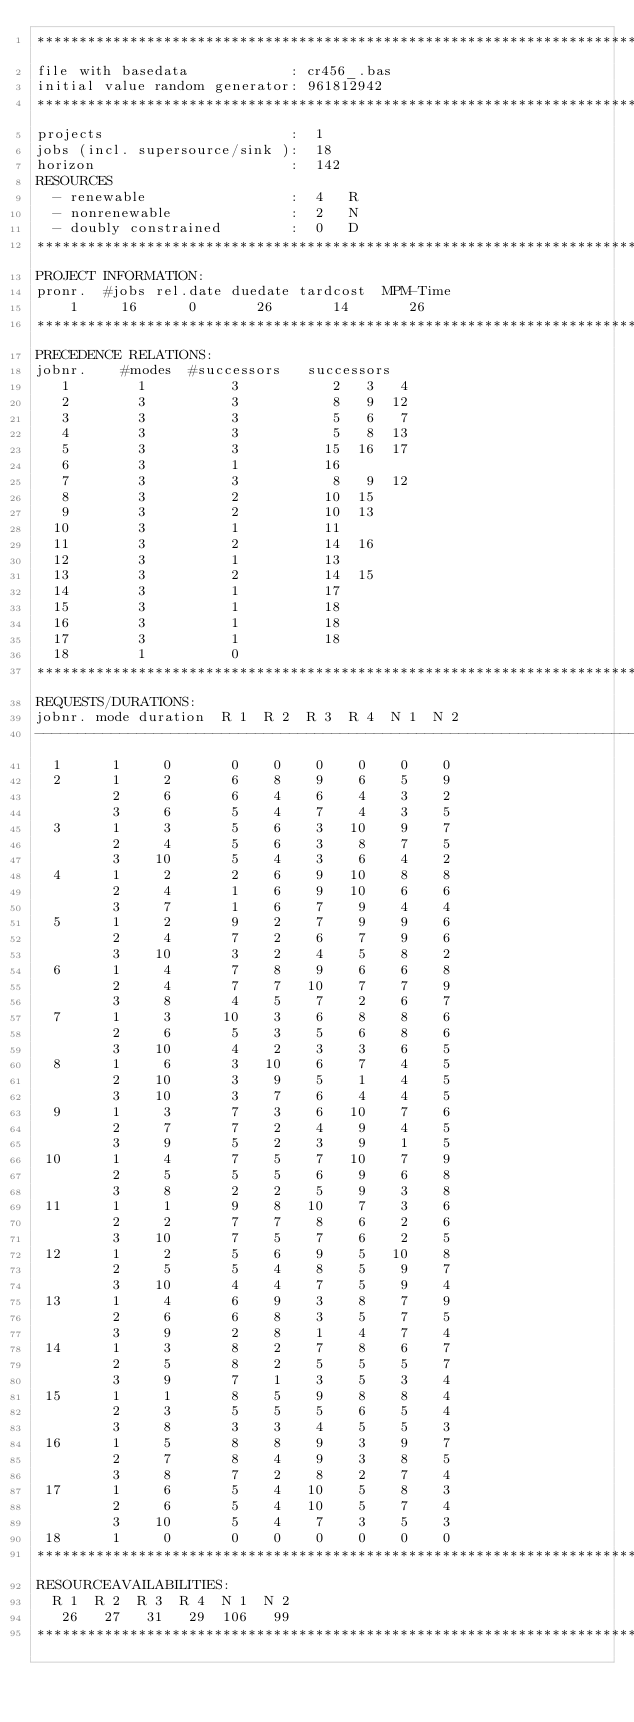<code> <loc_0><loc_0><loc_500><loc_500><_ObjectiveC_>************************************************************************
file with basedata            : cr456_.bas
initial value random generator: 961812942
************************************************************************
projects                      :  1
jobs (incl. supersource/sink ):  18
horizon                       :  142
RESOURCES
  - renewable                 :  4   R
  - nonrenewable              :  2   N
  - doubly constrained        :  0   D
************************************************************************
PROJECT INFORMATION:
pronr.  #jobs rel.date duedate tardcost  MPM-Time
    1     16      0       26       14       26
************************************************************************
PRECEDENCE RELATIONS:
jobnr.    #modes  #successors   successors
   1        1          3           2   3   4
   2        3          3           8   9  12
   3        3          3           5   6   7
   4        3          3           5   8  13
   5        3          3          15  16  17
   6        3          1          16
   7        3          3           8   9  12
   8        3          2          10  15
   9        3          2          10  13
  10        3          1          11
  11        3          2          14  16
  12        3          1          13
  13        3          2          14  15
  14        3          1          17
  15        3          1          18
  16        3          1          18
  17        3          1          18
  18        1          0        
************************************************************************
REQUESTS/DURATIONS:
jobnr. mode duration  R 1  R 2  R 3  R 4  N 1  N 2
------------------------------------------------------------------------
  1      1     0       0    0    0    0    0    0
  2      1     2       6    8    9    6    5    9
         2     6       6    4    6    4    3    2
         3     6       5    4    7    4    3    5
  3      1     3       5    6    3   10    9    7
         2     4       5    6    3    8    7    5
         3    10       5    4    3    6    4    2
  4      1     2       2    6    9   10    8    8
         2     4       1    6    9   10    6    6
         3     7       1    6    7    9    4    4
  5      1     2       9    2    7    9    9    6
         2     4       7    2    6    7    9    6
         3    10       3    2    4    5    8    2
  6      1     4       7    8    9    6    6    8
         2     4       7    7   10    7    7    9
         3     8       4    5    7    2    6    7
  7      1     3      10    3    6    8    8    6
         2     6       5    3    5    6    8    6
         3    10       4    2    3    3    6    5
  8      1     6       3   10    6    7    4    5
         2    10       3    9    5    1    4    5
         3    10       3    7    6    4    4    5
  9      1     3       7    3    6   10    7    6
         2     7       7    2    4    9    4    5
         3     9       5    2    3    9    1    5
 10      1     4       7    5    7   10    7    9
         2     5       5    5    6    9    6    8
         3     8       2    2    5    9    3    8
 11      1     1       9    8   10    7    3    6
         2     2       7    7    8    6    2    6
         3    10       7    5    7    6    2    5
 12      1     2       5    6    9    5   10    8
         2     5       5    4    8    5    9    7
         3    10       4    4    7    5    9    4
 13      1     4       6    9    3    8    7    9
         2     6       6    8    3    5    7    5
         3     9       2    8    1    4    7    4
 14      1     3       8    2    7    8    6    7
         2     5       8    2    5    5    5    7
         3     9       7    1    3    5    3    4
 15      1     1       8    5    9    8    8    4
         2     3       5    5    5    6    5    4
         3     8       3    3    4    5    5    3
 16      1     5       8    8    9    3    9    7
         2     7       8    4    9    3    8    5
         3     8       7    2    8    2    7    4
 17      1     6       5    4   10    5    8    3
         2     6       5    4   10    5    7    4
         3    10       5    4    7    3    5    3
 18      1     0       0    0    0    0    0    0
************************************************************************
RESOURCEAVAILABILITIES:
  R 1  R 2  R 3  R 4  N 1  N 2
   26   27   31   29  106   99
************************************************************************
</code> 